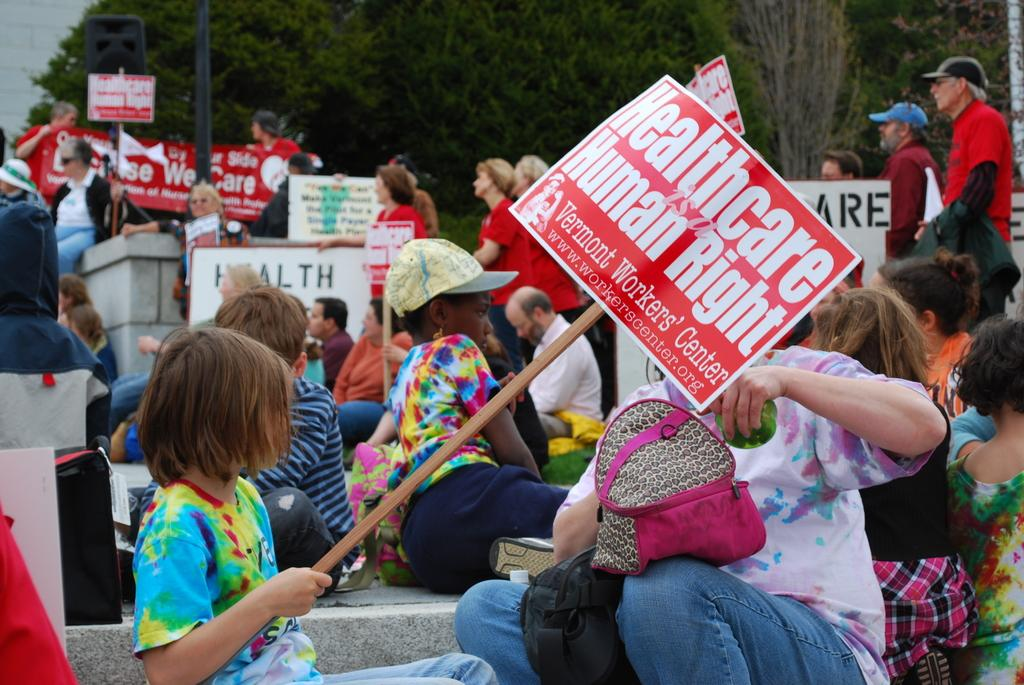What are the people in the image doing? There is a group of people sitting on the floor in the image, and they are holding boards. Can you describe the people in the background of the image? There are people standing in the background of the image. What can be seen in the background of the image besides the people? Trees are present in the background of the image. What type of power is being generated by the people in the image? There is no indication in the image that the people are generating any power. Can you tell me how many tramps are visible in the image? There are no tramps present in the image. 